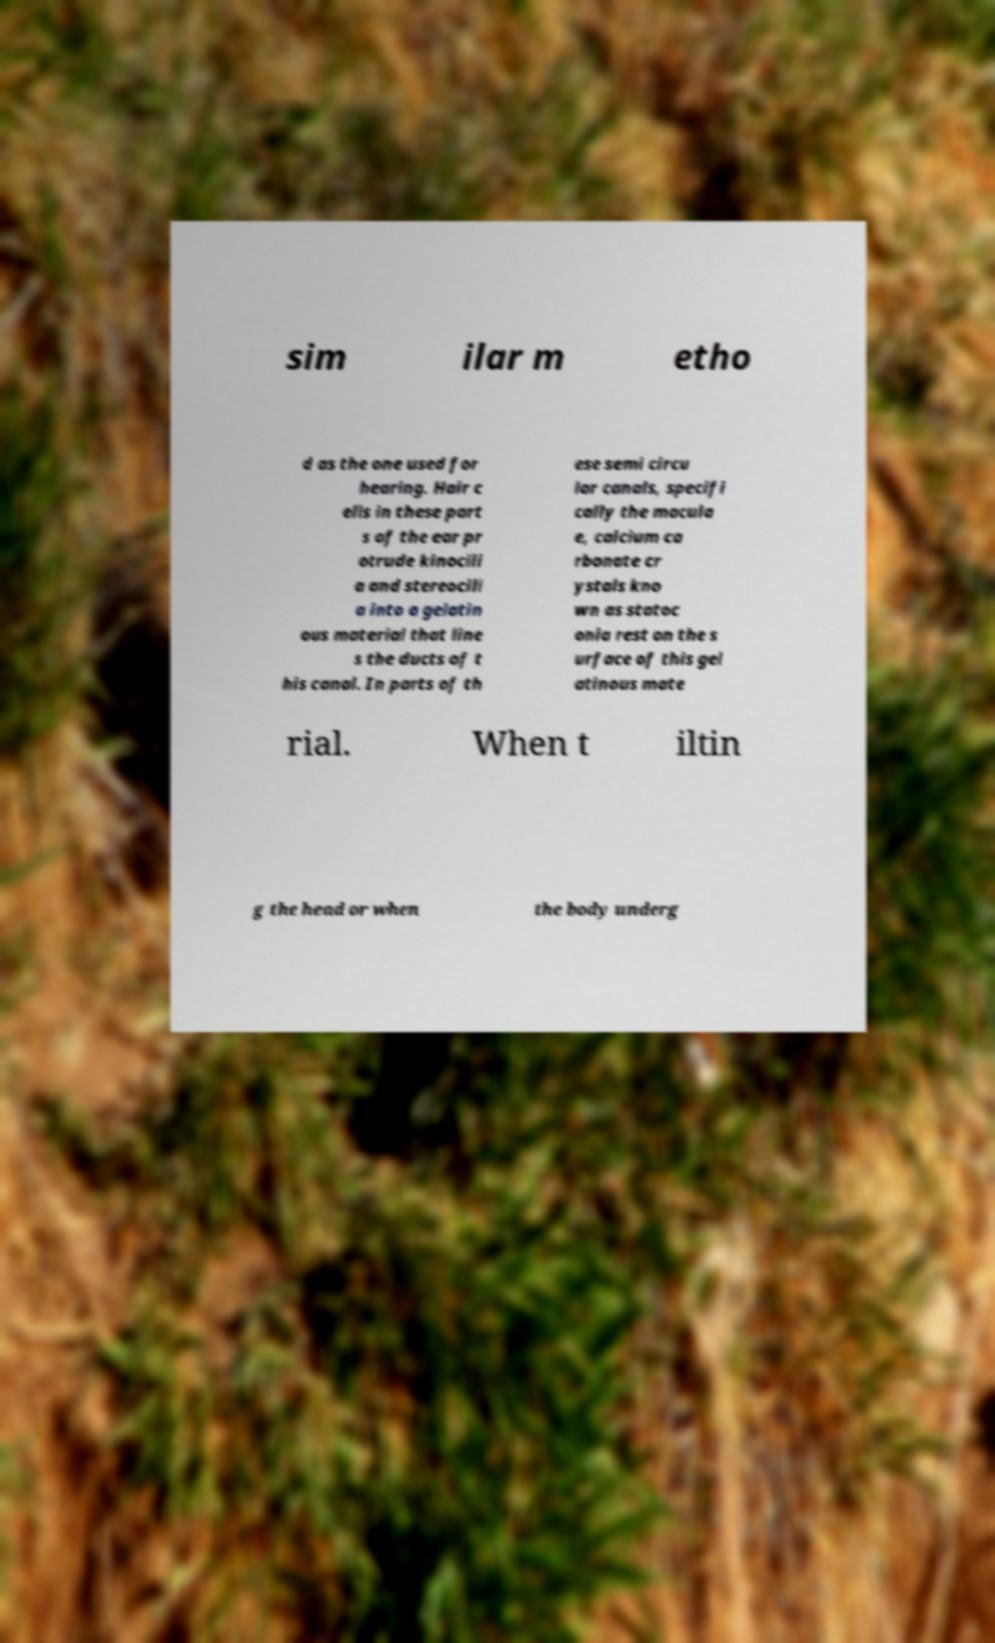Can you accurately transcribe the text from the provided image for me? sim ilar m etho d as the one used for hearing. Hair c ells in these part s of the ear pr otrude kinocili a and stereocili a into a gelatin ous material that line s the ducts of t his canal. In parts of th ese semi circu lar canals, specifi cally the macula e, calcium ca rbonate cr ystals kno wn as statoc onia rest on the s urface of this gel atinous mate rial. When t iltin g the head or when the body underg 